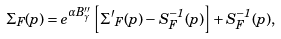Convert formula to latex. <formula><loc_0><loc_0><loc_500><loc_500>\Sigma _ { F } ( p ) = e ^ { \alpha B ^ { \prime \prime } _ { \gamma } } \left [ { \Sigma ^ { \prime } } _ { F } ( p ) - S ^ { - 1 } _ { F } ( p ) \right ] + S ^ { - 1 } _ { F } ( p ) ,</formula> 